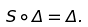<formula> <loc_0><loc_0><loc_500><loc_500>S \circ \Delta = \Delta .</formula> 